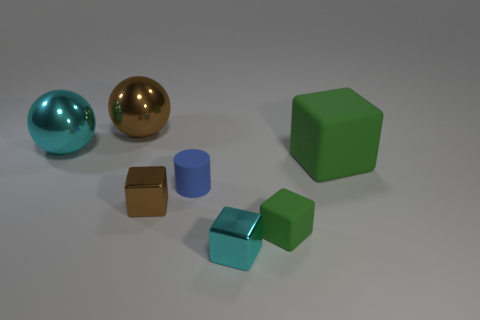Add 1 cyan shiny cylinders. How many objects exist? 8 Subtract all balls. How many objects are left? 5 Subtract all big purple cylinders. Subtract all tiny blue matte cylinders. How many objects are left? 6 Add 7 rubber blocks. How many rubber blocks are left? 9 Add 5 large rubber blocks. How many large rubber blocks exist? 6 Subtract 1 blue cylinders. How many objects are left? 6 